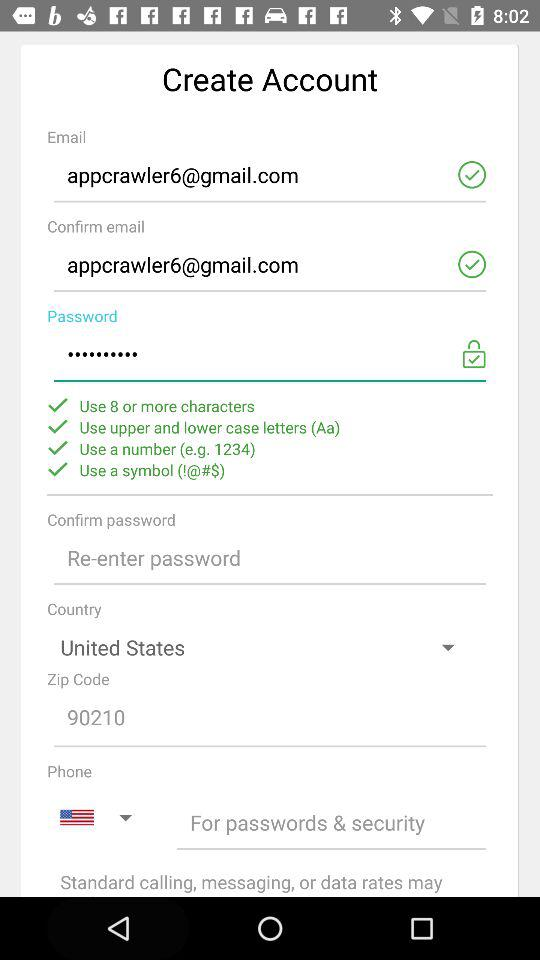How many minimum characters are required to set the password? The minimum characters required to set the password is 8. 